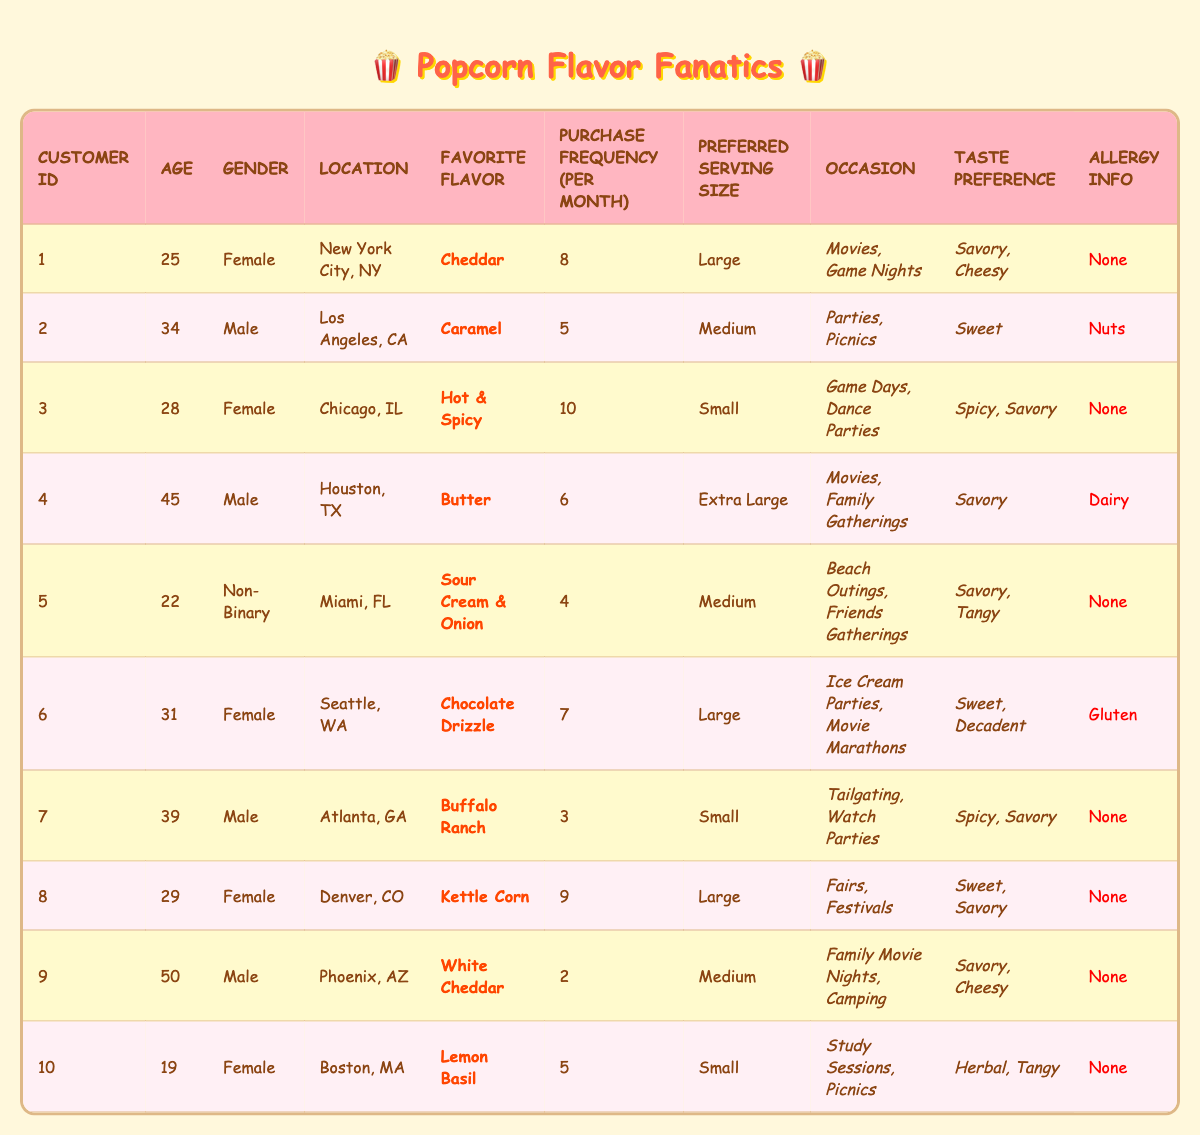What is the favorite flavor of the customer located in Los Angeles, CA? The customer from Los Angeles, CA is identified as CustomerID 2, who has "Caramel" listed as their favorite flavor.
Answer: Caramel How many customers have "Savory" as one of their taste preferences? By reviewing the table, I count the customers (1, 3, 4, 5, 7, 8, 9) who have "Savory" in their taste preference, totaling 7 customers.
Answer: 7 What is the age of the customer with the highest purchase frequency? CustomerID 3 has the highest purchase frequency of 10 per month and is 28 years old.
Answer: 28 Is any customer allergic to gluten, and if so, who? CustomerID 6 is the only one listed with an allergy to gluten.
Answer: Yes, CustomerID 6 What is the average age of all customers who prefer "Sweet" flavored popcorn? The customers who prefer "Sweet" flavors are CustomerID 2 (34), CustomerID 6 (31), and CustomerID 8 (29). Adding their ages gives us 34 + 31 + 29 = 94. Dividing by 3 for the average provides 94 / 3 = 31.33, which rounds to 31.
Answer: 31 Which locations have customers that enjoy "Spicy" flavors? Customers who enjoy "Spicy" flavors are from Chicago, IL (CustomerID 3), Atlanta, GA (CustomerID 7). Therefore, the locations with customers that enjoy "Spicy" flavors are Chicago, IL and Atlanta, GA.
Answer: Chicago, IL and Atlanta, GA What is the preferred serving size for customers who have no allergies? Looking at the customers with no allergies (CustomerID 1, 3, 5, 7, 8, 9, 10), their preferred serving sizes are Large, Small, Medium, Small, Large, Medium, Small. Conclusively, both "Large" and "Small" appear most frequently among these choices.
Answer: Large and Small How many customers purchase popcorn at least 6 times a month? Customers who purchase at least 6 times a month are CustomerID 1 (8), CustomerID 3 (10), CustomerID 4 (6), and CustomerID 6 (7): totaling 4 customers that meet this criterion.
Answer: 4 What is the total purchase frequency of customers who prefer "Savory" and "Cheesy" flavors? Customers with "Savory" and "Cheesy" preferences include CustomerID 1 (8), CustomerID 4 (6), CustomerID 9 (2), resulting in a total purchase frequency of 8 + 6 + 2 = 16.
Answer: 16 What percentage of female customers prefer "Cheddar"? There are a total of 5 female customers (IDs: 1, 3, 6, 8, 10), and only CustomerID 1 prefers "Cheddar." Thus, the percentage is calculated as (1/5) * 100 = 20%.
Answer: 20% 